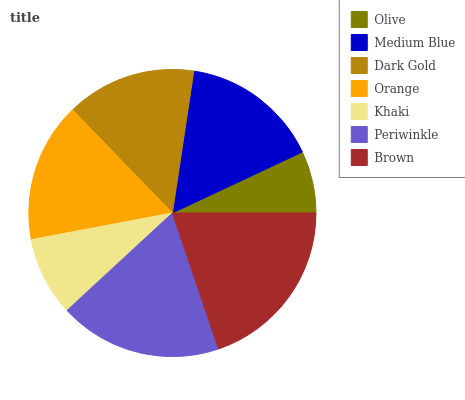Is Olive the minimum?
Answer yes or no. Yes. Is Brown the maximum?
Answer yes or no. Yes. Is Medium Blue the minimum?
Answer yes or no. No. Is Medium Blue the maximum?
Answer yes or no. No. Is Medium Blue greater than Olive?
Answer yes or no. Yes. Is Olive less than Medium Blue?
Answer yes or no. Yes. Is Olive greater than Medium Blue?
Answer yes or no. No. Is Medium Blue less than Olive?
Answer yes or no. No. Is Medium Blue the high median?
Answer yes or no. Yes. Is Medium Blue the low median?
Answer yes or no. Yes. Is Olive the high median?
Answer yes or no. No. Is Periwinkle the low median?
Answer yes or no. No. 